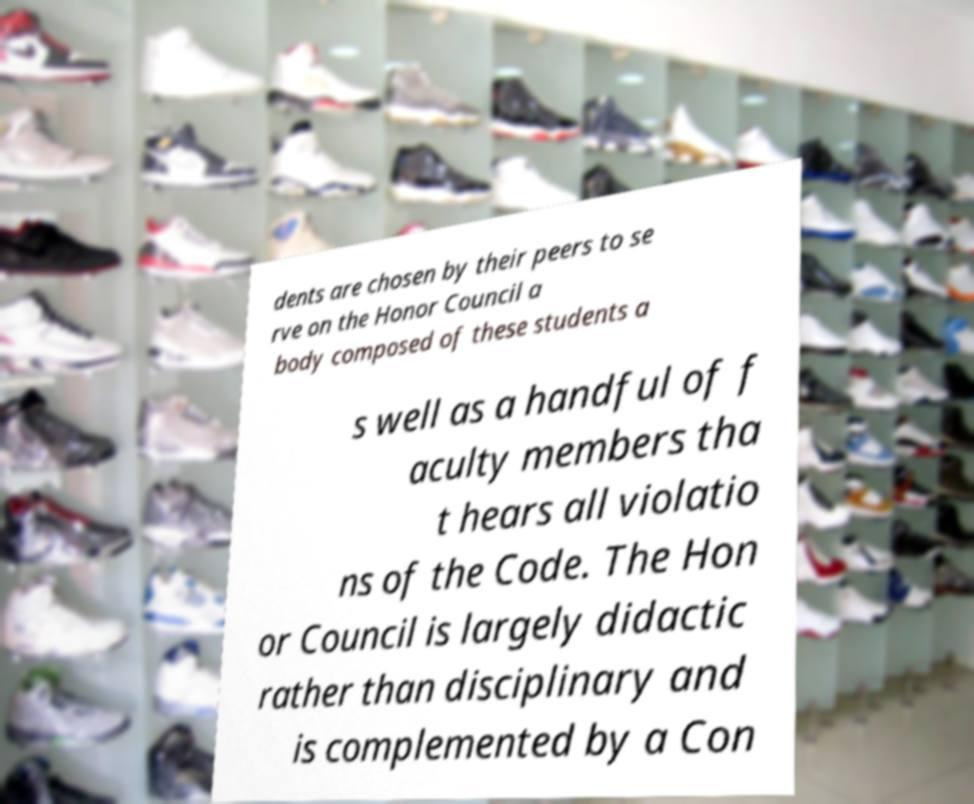Can you read and provide the text displayed in the image?This photo seems to have some interesting text. Can you extract and type it out for me? dents are chosen by their peers to se rve on the Honor Council a body composed of these students a s well as a handful of f aculty members tha t hears all violatio ns of the Code. The Hon or Council is largely didactic rather than disciplinary and is complemented by a Con 